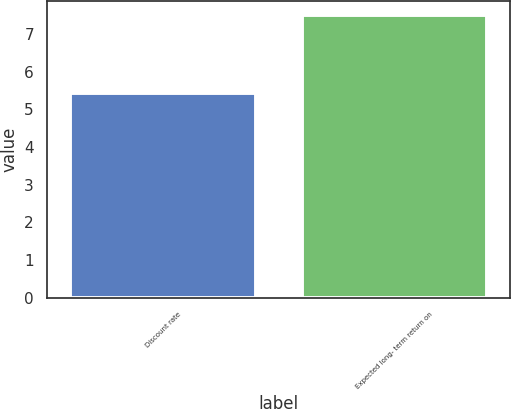<chart> <loc_0><loc_0><loc_500><loc_500><bar_chart><fcel>Discount rate<fcel>Expected long- term return on<nl><fcel>5.44<fcel>7.5<nl></chart> 